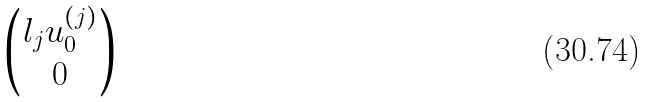Convert formula to latex. <formula><loc_0><loc_0><loc_500><loc_500>\begin{pmatrix} l _ { j } u _ { 0 } ^ { ( j ) } \\ 0 \\ \end{pmatrix}</formula> 